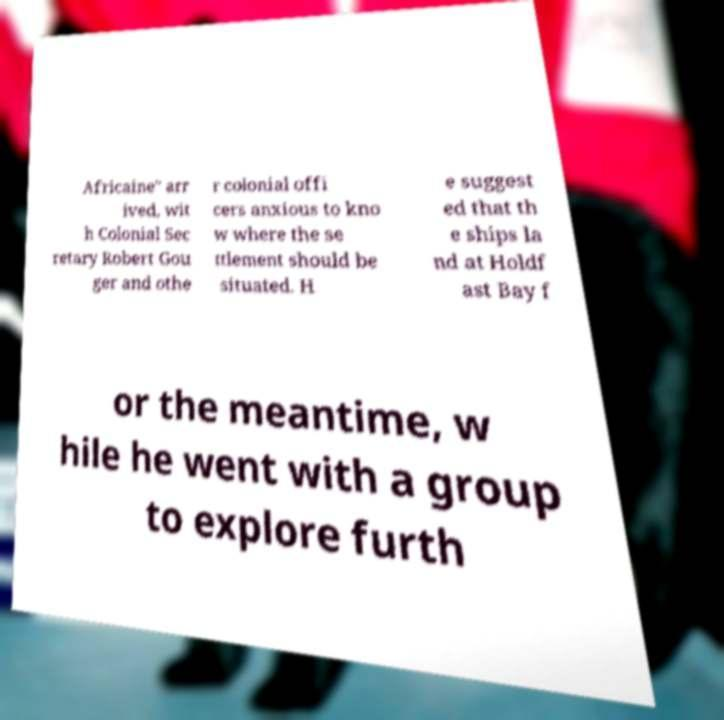Could you extract and type out the text from this image? Africaine" arr ived, wit h Colonial Sec retary Robert Gou ger and othe r colonial offi cers anxious to kno w where the se ttlement should be situated. H e suggest ed that th e ships la nd at Holdf ast Bay f or the meantime, w hile he went with a group to explore furth 